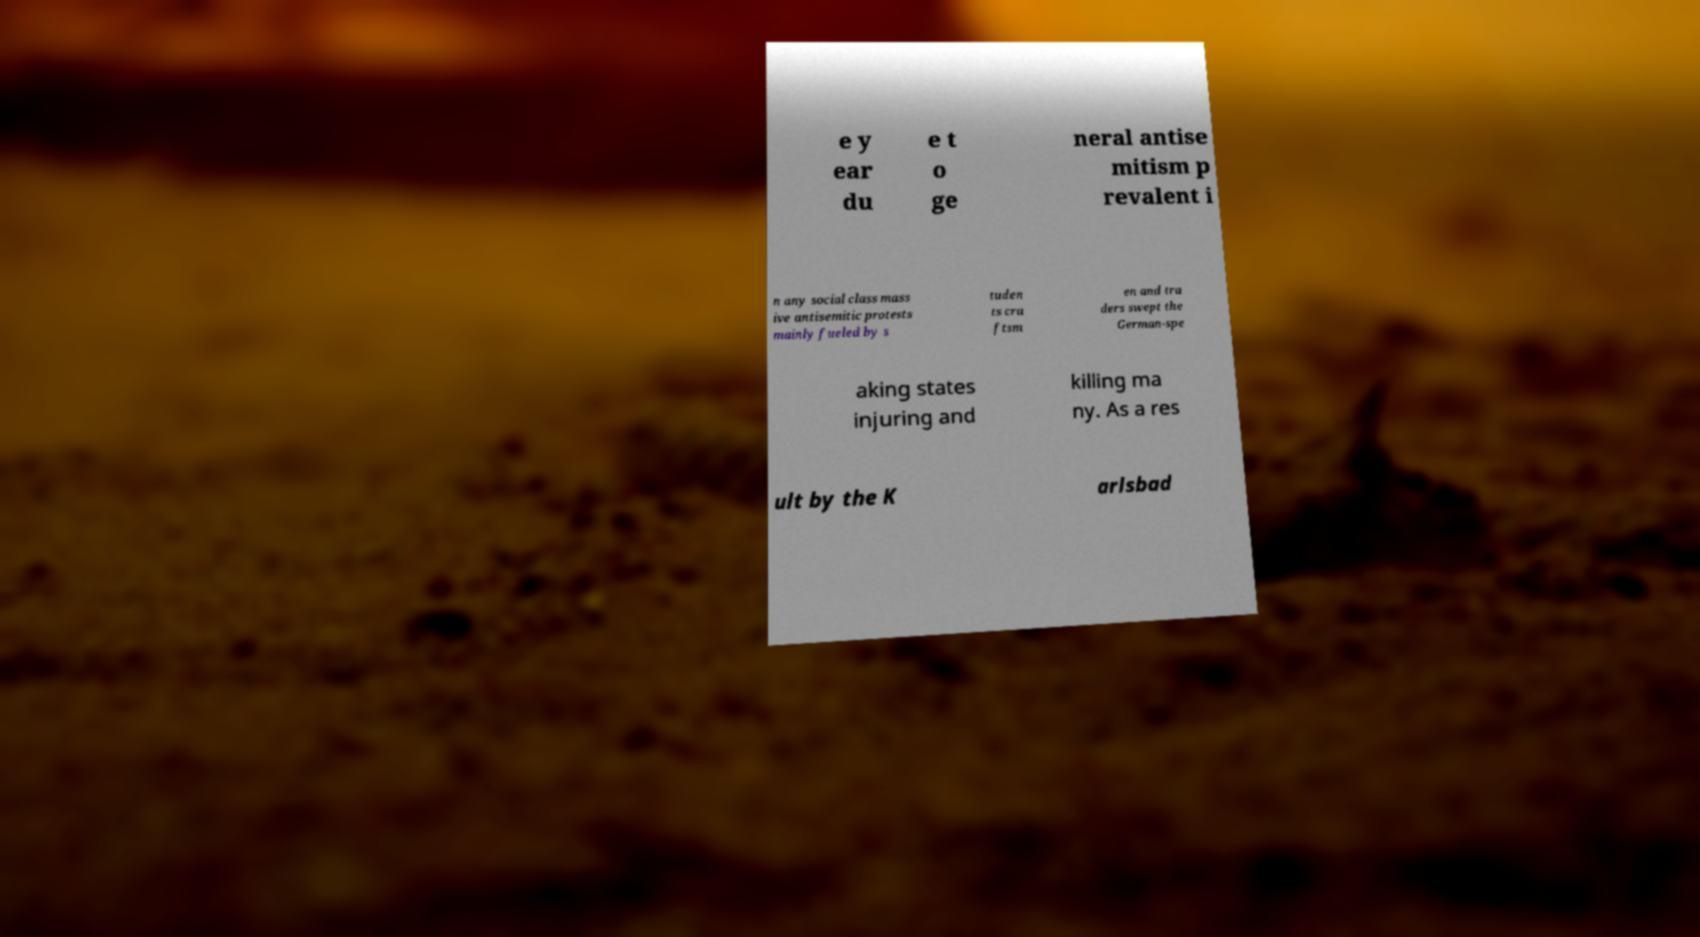Could you assist in decoding the text presented in this image and type it out clearly? e y ear du e t o ge neral antise mitism p revalent i n any social class mass ive antisemitic protests mainly fueled by s tuden ts cra ftsm en and tra ders swept the German-spe aking states injuring and killing ma ny. As a res ult by the K arlsbad 